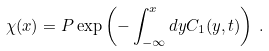<formula> <loc_0><loc_0><loc_500><loc_500>\chi ( x ) = P \exp \left ( - \int ^ { x } _ { - \infty } d y C _ { 1 } ( y , t ) \right ) \, .</formula> 